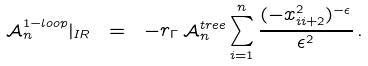Convert formula to latex. <formula><loc_0><loc_0><loc_500><loc_500>\mathcal { A } ^ { 1 - l o o p } _ { n } | _ { I R } \ = \ - r _ { \Gamma } \, \mathcal { A } ^ { t r e e } _ { n } \sum _ { i = 1 } ^ { n } \frac { ( - x _ { i i + 2 } ^ { 2 } ) ^ { - \epsilon } } { \epsilon ^ { 2 } } \, .</formula> 